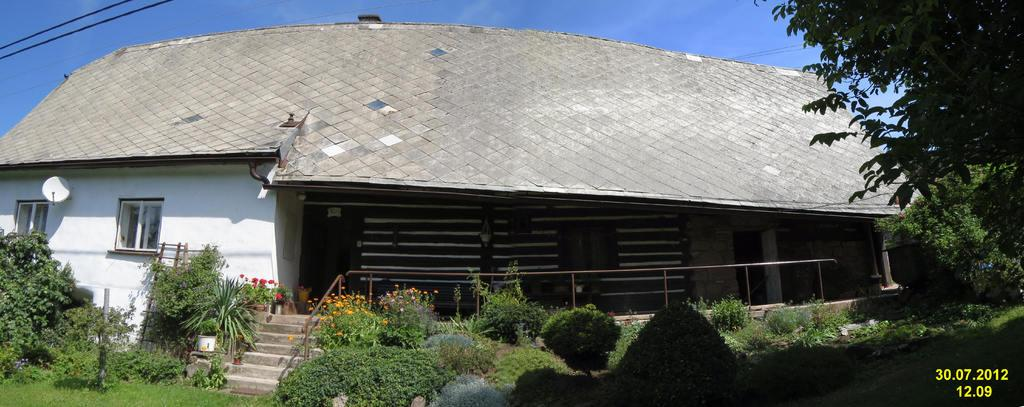What type of structures can be seen in the image? There are buildings in the image. What architectural features are present in the image? There are windows, stairs, and fencing in the image. What type of vegetation is visible in the image? There are small plants and trees in the image. What is the color of the sky in the image? The sky is blue in color. How many kittens are playing with dolls under a veil in the image? There are no kittens, dolls, or veils present in the image. 